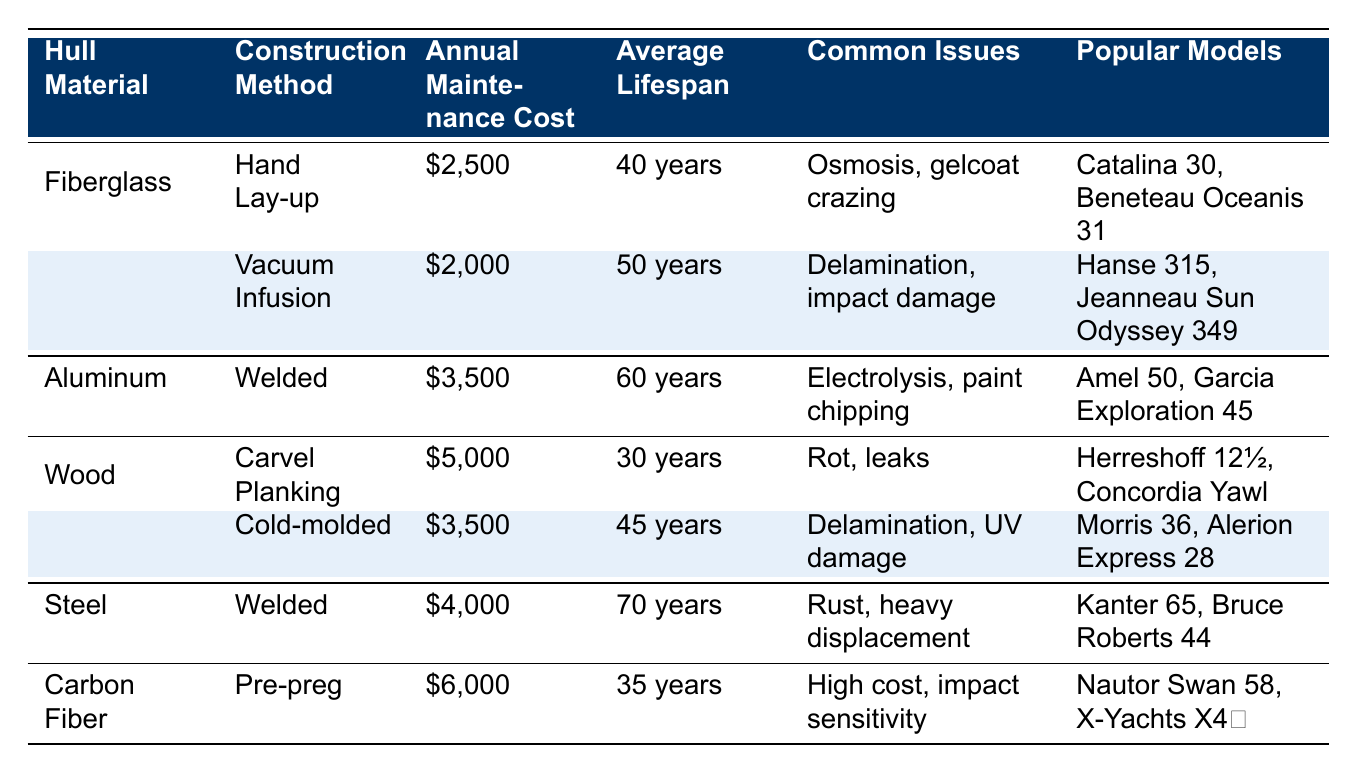What is the annual maintenance cost for a fiberglass sailboat using vacuum infusion? The table directly lists the annual maintenance cost for the fiberglass construction method 'Vacuum Infusion' as $2,000.
Answer: $2,000 Which hull material has the highest average lifespan? Looking at the average lifespan across all hull materials, 'Steel' has an average lifespan of 70 years, which is greater than all the others.
Answer: Steel Are there more common issues listed for wood boats compared to fiberglass boats? Fiberglass boats have two common issues listed, whereas wood boats also have two common issues listed. Therefore, the number of issues is the same.
Answer: No What is the difference in annual maintenance costs between aluminum and carbon fiber sailboats? The annual maintenance cost for aluminum is $3,500, while for carbon fiber it is $6,000. The difference is calculated as $6,000 - $3,500 = $2,500.
Answer: $2,500 Which hull material type has the most popular models listed? The table lists popular models for each hull material. 'Wood' has two construction methods (Carvel Planking and Cold-molded), giving it a total of four models listed. 'Fiberglass' has two models, 'Aluminum' has two models, 'Steel' has two models, and 'Carbon Fiber' has two models. Therefore, 'Wood' leads with the most models.
Answer: Wood If a sailor wishes to have a boat with a lifespan of at least 50 years, which materials should they consider? According to the table, the hull materials 'Aluminum' (60 years), 'Steel' (70 years), and 'Fiberglass' with 'Vacuum Infusion' (50 years) meet this criterion.
Answer: Aluminum, Steel, Fiberglass (Vacuum Infusion) Which construction method has the lowest annual maintenance cost? The lowest annual maintenance cost listed in the table is for 'Fiberglass' using the 'Vacuum Infusion' method, which costs $2,000.
Answer: Vacuum Infusion Is the maintenance cost for the wooden construction method higher than that of the welded aluminum construction method? The maintenance cost for wooden 'Carvel Planking' is $5,000, while for aluminum it’s $3,500. Since $5,000 is greater than $3,500, the answer is yes.
Answer: Yes What is the average lifespan of the wood construction methods? The average lifespan includes 30 years for Carvel Planking and 45 years for Cold-molded. To calculate the average: (30 + 45) / 2 = 37.5 years.
Answer: 37.5 years Which hull material has the least common issues associated with it? Analyzing the common issues, 'Aluminum' has only one issue: Electrolysis and paint chipping, while all others have two or more.
Answer: Aluminum Which construction method has a lifespan that is 15 years longer than its maintenance cost indicates? Comparing the annual maintenance cost and lifespan, 'Welded' Steel has a maintenance cost of $4,000 and a lifespan of 70 years. This suggests that it is well-balanced when lifespan considerably exceeds maintenance cost.
Answer: Welded Steel 